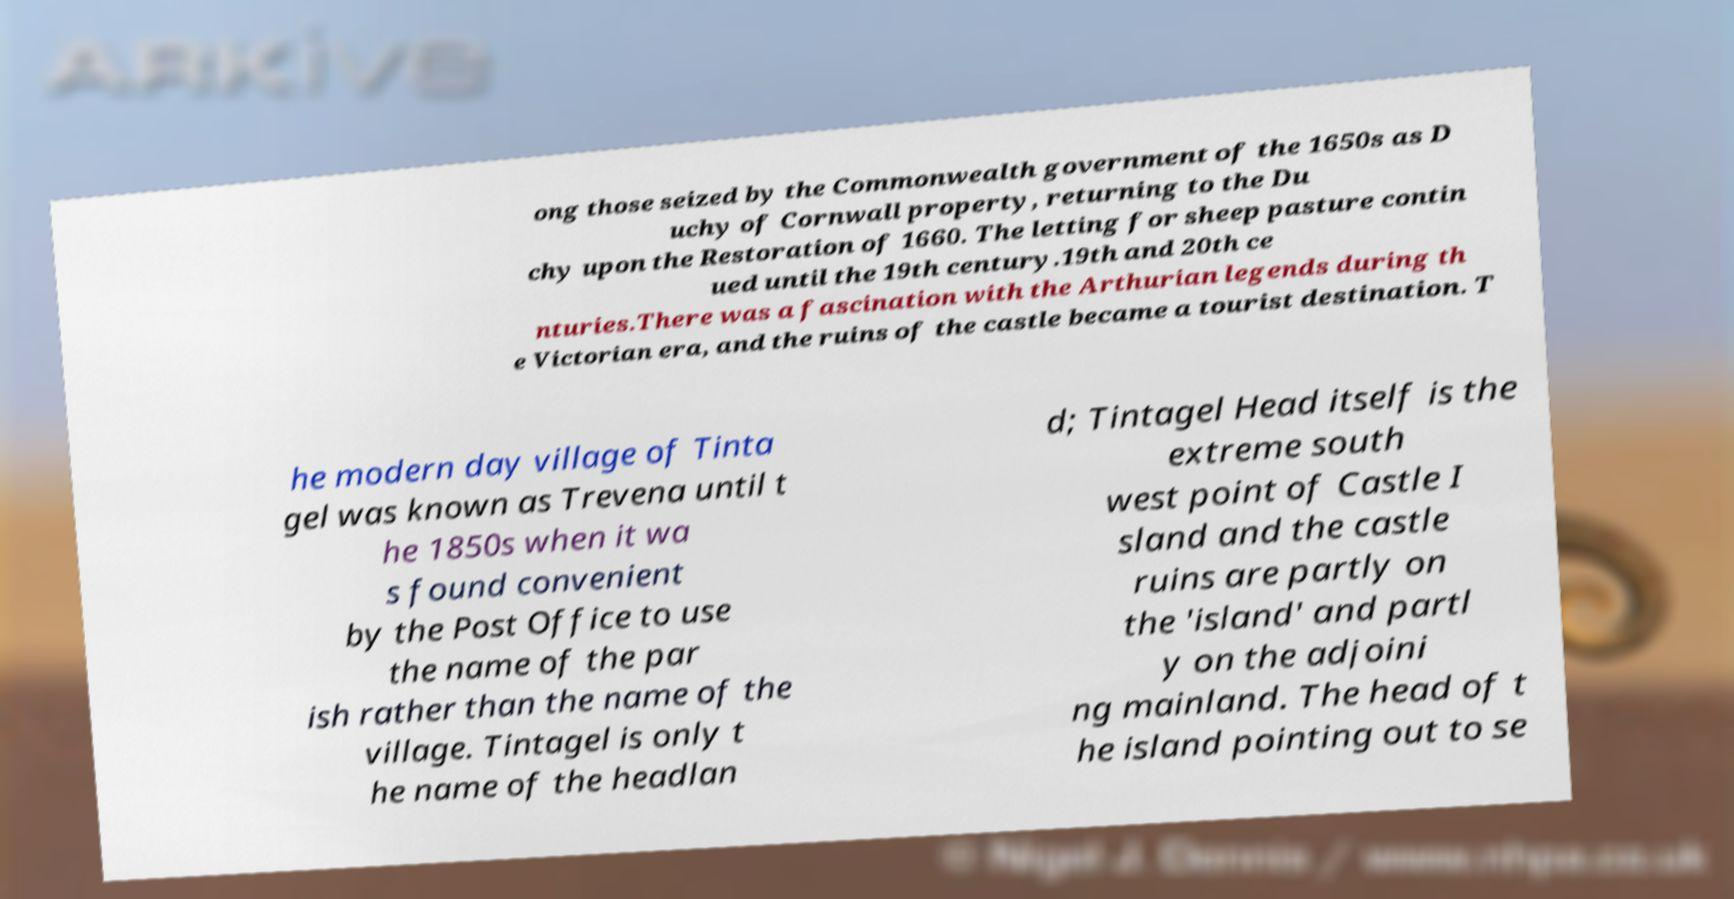Could you assist in decoding the text presented in this image and type it out clearly? ong those seized by the Commonwealth government of the 1650s as D uchy of Cornwall property, returning to the Du chy upon the Restoration of 1660. The letting for sheep pasture contin ued until the 19th century.19th and 20th ce nturies.There was a fascination with the Arthurian legends during th e Victorian era, and the ruins of the castle became a tourist destination. T he modern day village of Tinta gel was known as Trevena until t he 1850s when it wa s found convenient by the Post Office to use the name of the par ish rather than the name of the village. Tintagel is only t he name of the headlan d; Tintagel Head itself is the extreme south west point of Castle I sland and the castle ruins are partly on the 'island' and partl y on the adjoini ng mainland. The head of t he island pointing out to se 